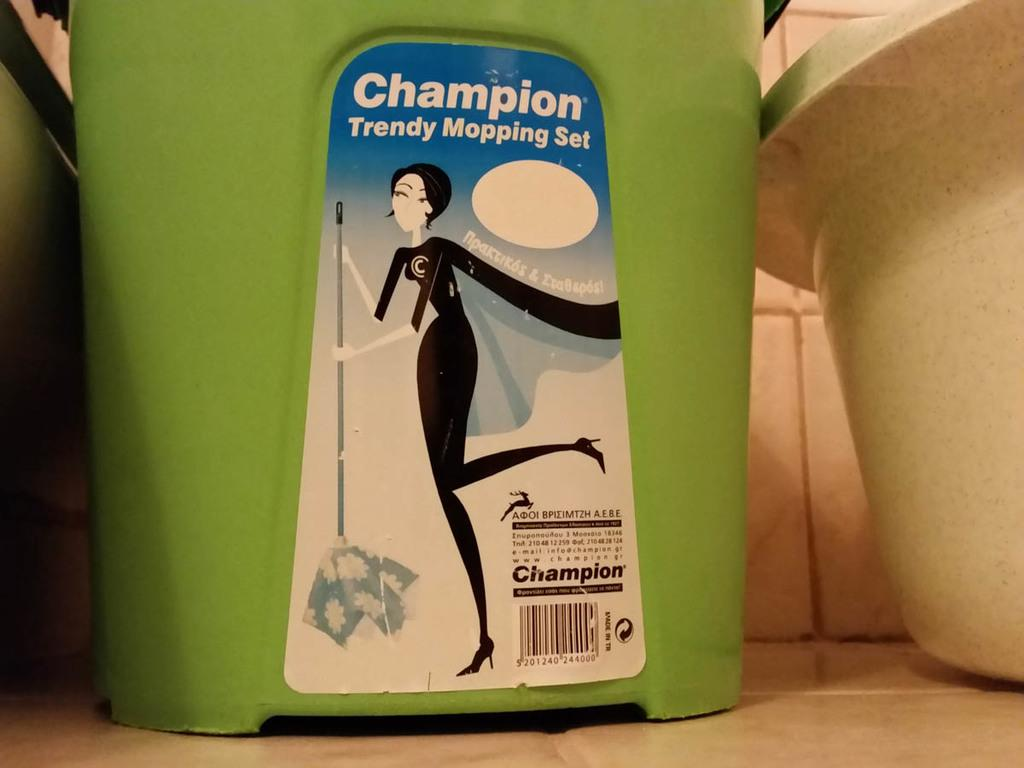What color is the mop tub in the image? The mop tub in the image is green. What is on the mop tub in the image? The green mop tub has a sticker on it. What is on the right side of the image? There is a plastic tub on the right side of the image. What type of flooring is visible in the image? There are tiles visible in the image. What type of silk material is draped over the sink in the image? There is no silk material or sink present in the image. How many giraffes can be seen in the image? There are no giraffes present in the image. 